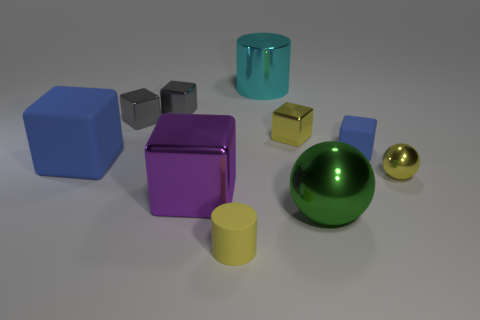Subtract all blue rubber blocks. How many blocks are left? 4 Subtract all purple cubes. How many cubes are left? 5 Subtract all purple blocks. Subtract all green spheres. How many blocks are left? 5 Subtract all cylinders. How many objects are left? 8 Add 9 big purple objects. How many big purple objects are left? 10 Add 4 yellow shiny things. How many yellow shiny things exist? 6 Subtract 2 gray blocks. How many objects are left? 8 Subtract all brown metallic things. Subtract all tiny metallic cubes. How many objects are left? 7 